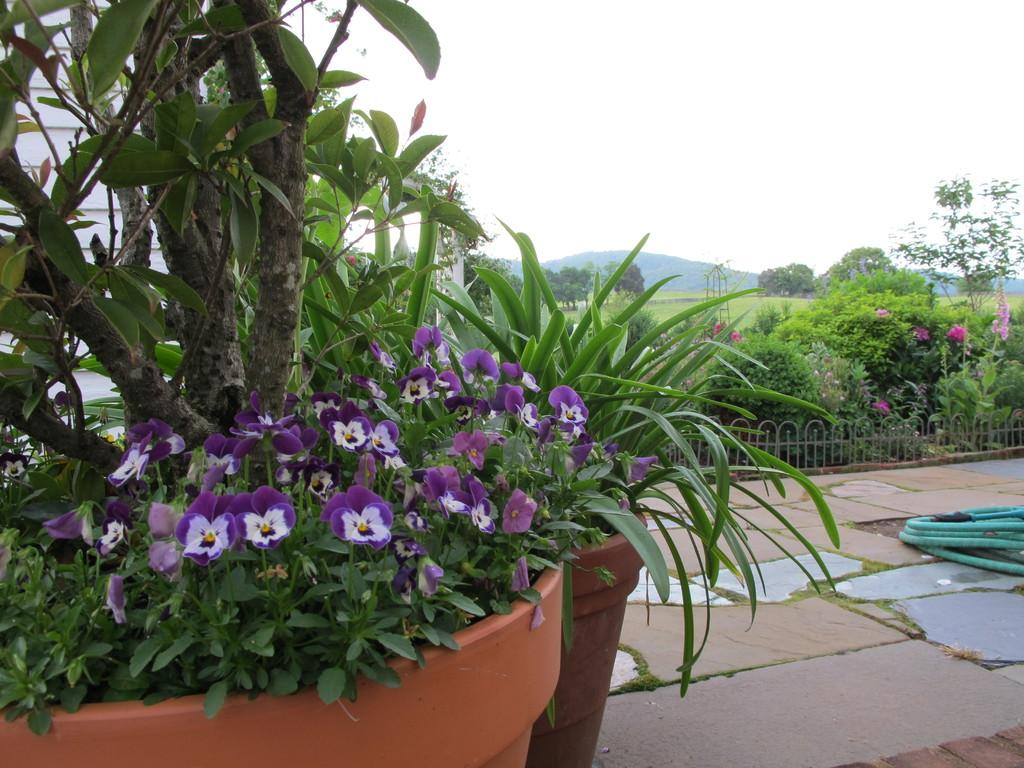What type of vegetation can be seen in the image? There are trees in the image. What objects are present for planting purposes? There are flower pots in the image. What type of barrier is visible in the image? There is fencing in the image. What man-made structure can be seen in the image? There is a pipe in the image. What natural landmarks are visible in the image? There are mountains in the image. What colors of flowers can be seen in the image? There are pink, purple, and white flowers in the image. What is the color of the sky in the image? The sky appears to be white in color. Can you describe the earthquake happening in the image? There is no earthquake depicted in the image. How many bees are buzzing around the flowers in the image? There are no bees present in the image. 